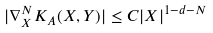<formula> <loc_0><loc_0><loc_500><loc_500>| \nabla _ { X } ^ { N } K _ { A } ( X , Y ) | \leq C | X | ^ { 1 - d - N }</formula> 